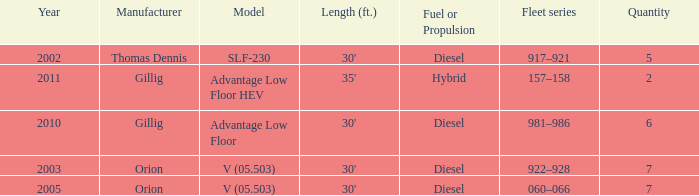Inform me of the model with diesel fuel or propulsion from the orion manufacturer in 200 V (05.503). 